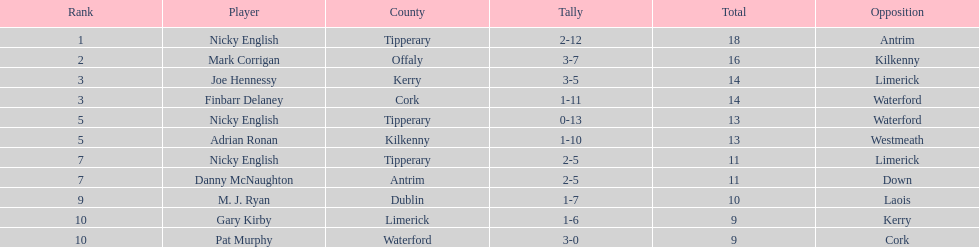Who had a superior rank to mark corrigan? Nicky English. 